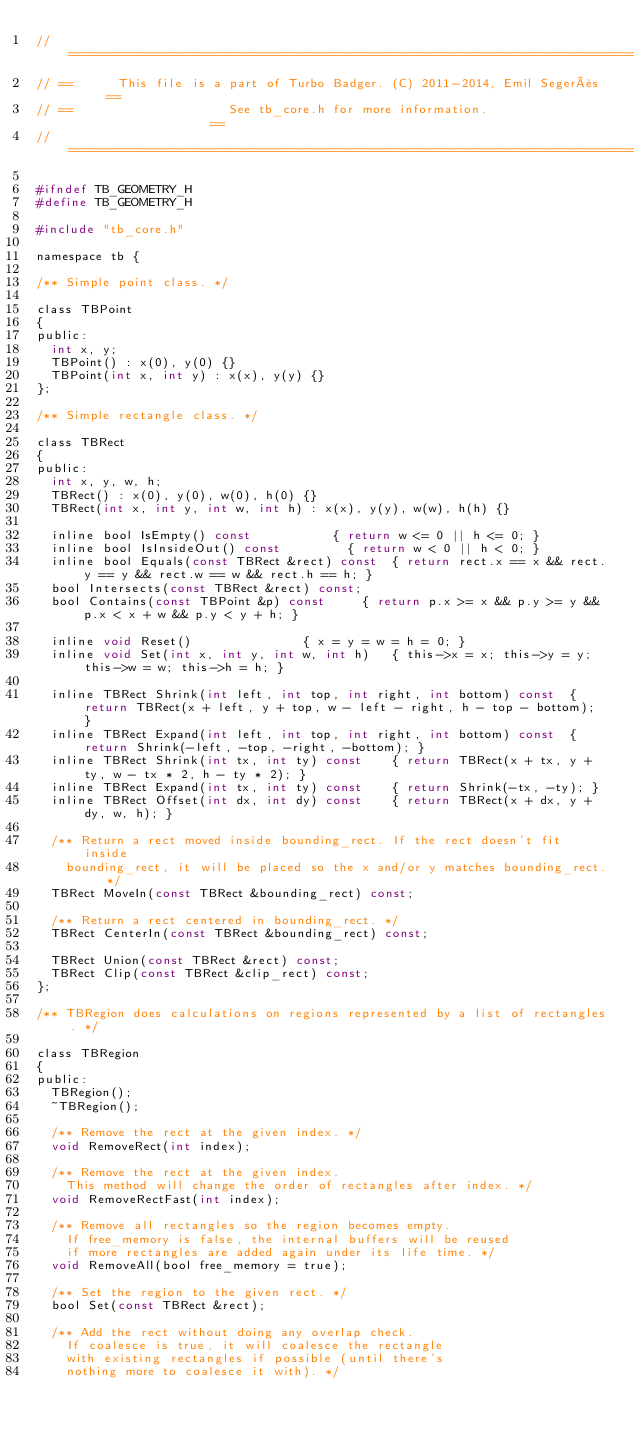Convert code to text. <code><loc_0><loc_0><loc_500><loc_500><_C_>// ================================================================================
// ==      This file is a part of Turbo Badger. (C) 2011-2014, Emil Segerås      ==
// ==                     See tb_core.h for more information.                    ==
// ================================================================================

#ifndef TB_GEOMETRY_H
#define TB_GEOMETRY_H

#include "tb_core.h"

namespace tb {

/** Simple point class. */

class TBPoint
{
public:
	int x, y;
	TBPoint() : x(0), y(0) {}
	TBPoint(int x, int y) : x(x), y(y) {}
};

/** Simple rectangle class. */

class TBRect
{
public:
	int x, y, w, h;
	TBRect() : x(0), y(0), w(0), h(0) {}
	TBRect(int x, int y, int w, int h) : x(x), y(y), w(w), h(h) {}

	inline bool IsEmpty() const						{ return w <= 0 || h <= 0; }
	inline bool IsInsideOut() const					{ return w < 0 || h < 0; }
	inline bool Equals(const TBRect &rect) const	{ return rect.x == x && rect.y == y && rect.w == w && rect.h == h; }
	bool Intersects(const TBRect &rect) const;
	bool Contains(const TBPoint &p) const			{ return p.x >= x && p.y >= y && p.x < x + w && p.y < y + h; }

	inline void Reset()								{ x = y = w = h = 0; }
	inline void Set(int x, int y, int w, int h)		{ this->x = x; this->y = y; this->w = w; this->h = h; }

	inline TBRect Shrink(int left, int top, int right, int bottom) const	{ return TBRect(x + left, y + top, w - left - right, h - top - bottom); }
	inline TBRect Expand(int left, int top, int right, int bottom) const	{ return Shrink(-left, -top, -right, -bottom); }
	inline TBRect Shrink(int tx, int ty) const		{ return TBRect(x + tx, y + ty, w - tx * 2, h - ty * 2); }
	inline TBRect Expand(int tx, int ty) const		{ return Shrink(-tx, -ty); }
	inline TBRect Offset(int dx, int dy) const		{ return TBRect(x + dx, y + dy, w, h); }

	/** Return a rect moved inside bounding_rect. If the rect doesn't fit inside
		bounding_rect, it will be placed so the x and/or y matches bounding_rect. */
	TBRect MoveIn(const TBRect &bounding_rect) const;

	/** Return a rect centered in bounding_rect. */
	TBRect CenterIn(const TBRect &bounding_rect) const;

	TBRect Union(const TBRect &rect) const;
	TBRect Clip(const TBRect &clip_rect) const;
};

/** TBRegion does calculations on regions represented by a list of rectangles. */

class TBRegion
{
public:
	TBRegion();
	~TBRegion();

	/** Remove the rect at the given index. */
	void RemoveRect(int index);

	/** Remove the rect at the given index.
		This method will change the order of rectangles after index. */
	void RemoveRectFast(int index);

	/** Remove all rectangles so the region becomes empty.
		If free_memory is false, the internal buffers will be reused
		if more rectangles are added again under its life time. */
	void RemoveAll(bool free_memory = true);

	/** Set the region to the given rect. */
	bool Set(const TBRect &rect);

	/** Add the rect without doing any overlap check.
		If coalesce is true, it will coalesce the rectangle
		with existing rectangles if possible (until there's
		nothing more to coalesce it with). */</code> 